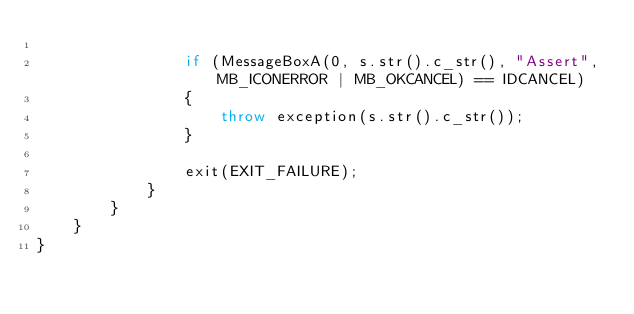Convert code to text. <code><loc_0><loc_0><loc_500><loc_500><_C++_>
				if (MessageBoxA(0, s.str().c_str(), "Assert", MB_ICONERROR | MB_OKCANCEL) == IDCANCEL)
				{
					throw exception(s.str().c_str());
				}

				exit(EXIT_FAILURE);
			}
		}
	}
}</code> 